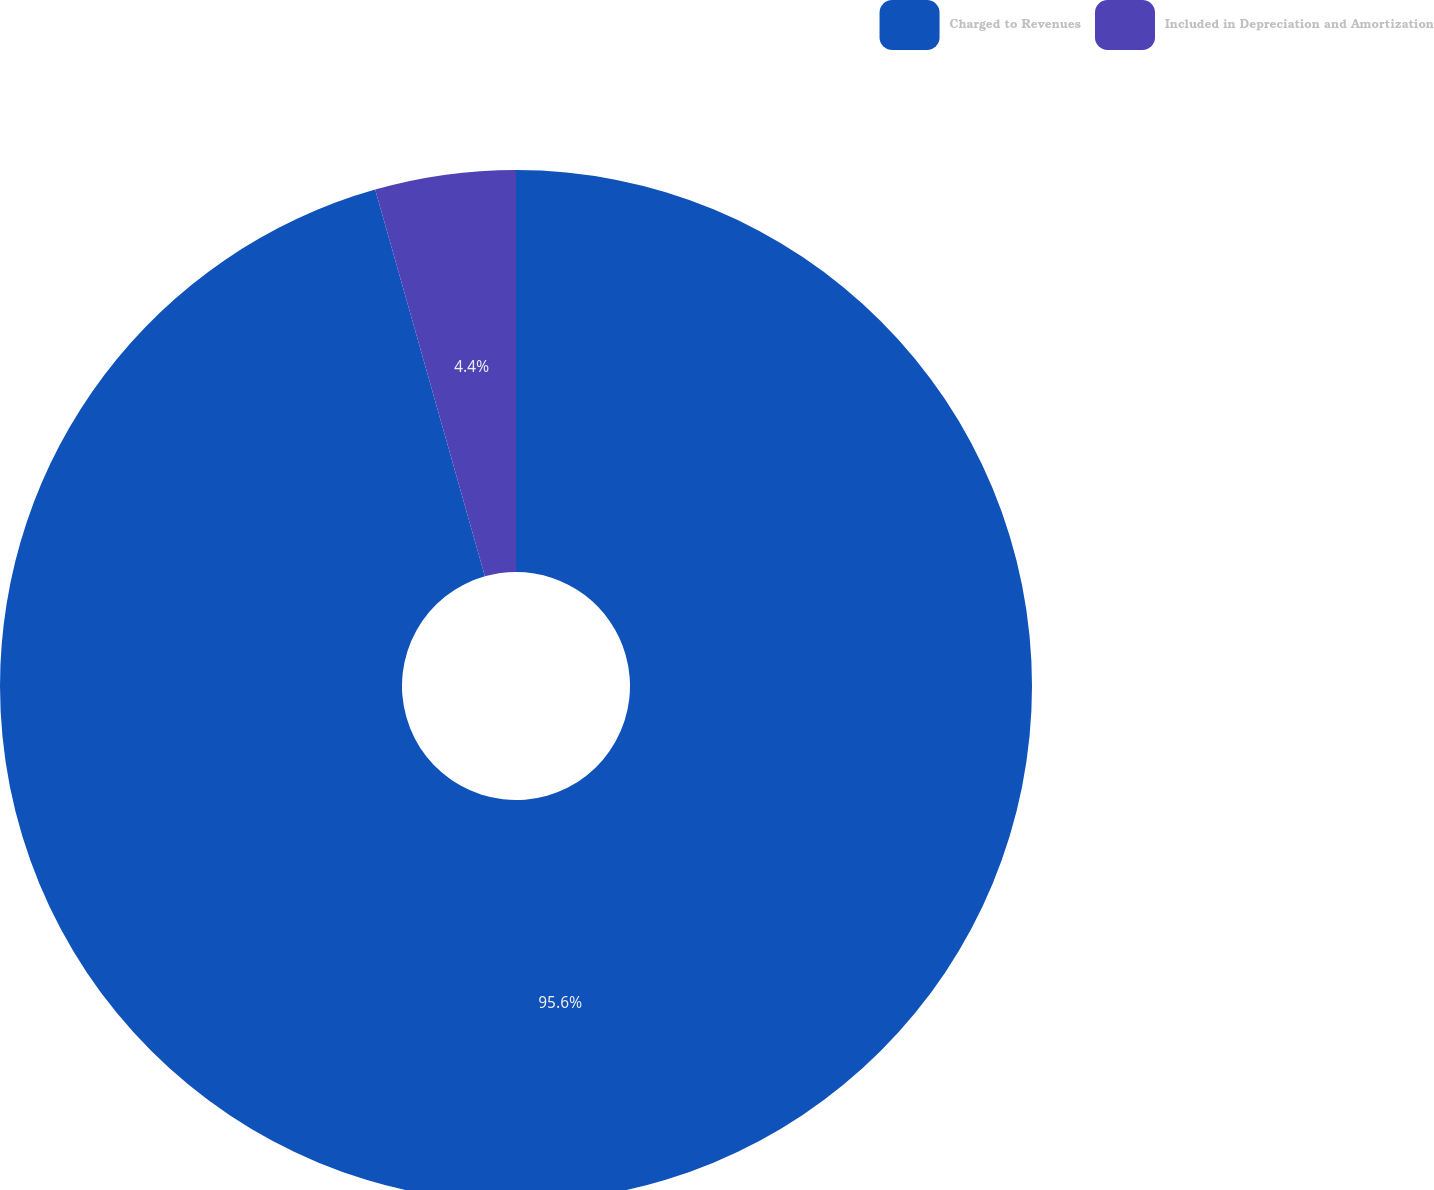Convert chart. <chart><loc_0><loc_0><loc_500><loc_500><pie_chart><fcel>Charged to Revenues<fcel>Included in Depreciation and Amortization<nl><fcel>95.6%<fcel>4.4%<nl></chart> 